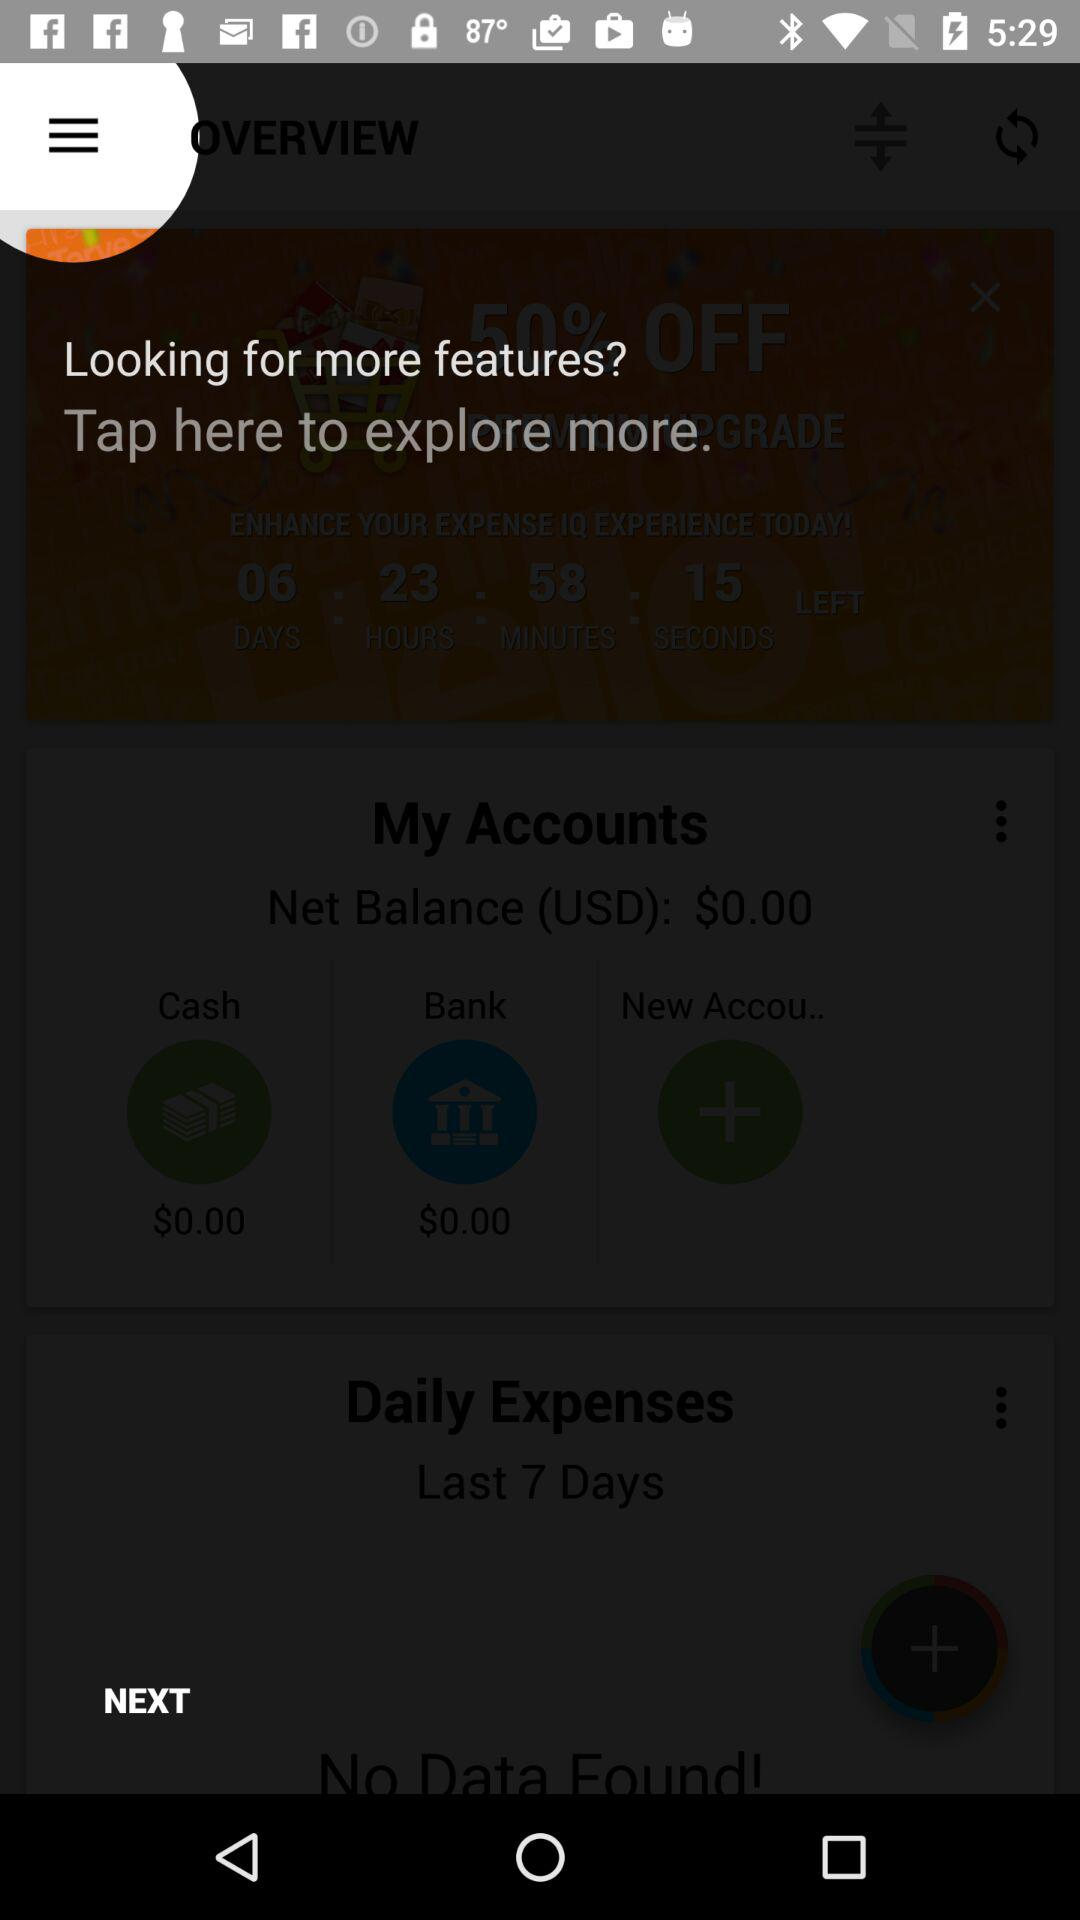How many more accounts are there than cash?
Answer the question using a single word or phrase. 1 